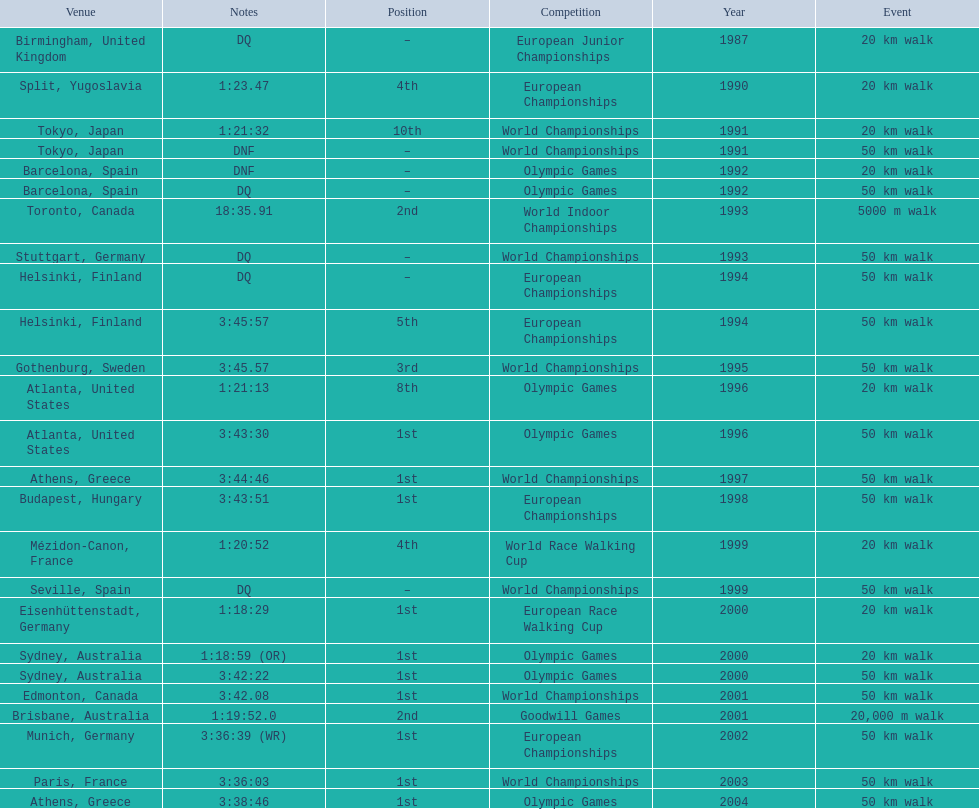In 1990 what position did robert korzeniowski place? 4th. Could you parse the entire table? {'header': ['Venue', 'Notes', 'Position', 'Competition', 'Year', 'Event'], 'rows': [['Birmingham, United Kingdom', 'DQ', '–', 'European Junior Championships', '1987', '20\xa0km walk'], ['Split, Yugoslavia', '1:23.47', '4th', 'European Championships', '1990', '20\xa0km walk'], ['Tokyo, Japan', '1:21:32', '10th', 'World Championships', '1991', '20\xa0km walk'], ['Tokyo, Japan', 'DNF', '–', 'World Championships', '1991', '50\xa0km walk'], ['Barcelona, Spain', 'DNF', '–', 'Olympic Games', '1992', '20\xa0km walk'], ['Barcelona, Spain', 'DQ', '–', 'Olympic Games', '1992', '50\xa0km walk'], ['Toronto, Canada', '18:35.91', '2nd', 'World Indoor Championships', '1993', '5000 m walk'], ['Stuttgart, Germany', 'DQ', '–', 'World Championships', '1993', '50\xa0km walk'], ['Helsinki, Finland', 'DQ', '–', 'European Championships', '1994', '50\xa0km walk'], ['Helsinki, Finland', '3:45:57', '5th', 'European Championships', '1994', '50\xa0km walk'], ['Gothenburg, Sweden', '3:45.57', '3rd', 'World Championships', '1995', '50\xa0km walk'], ['Atlanta, United States', '1:21:13', '8th', 'Olympic Games', '1996', '20\xa0km walk'], ['Atlanta, United States', '3:43:30', '1st', 'Olympic Games', '1996', '50\xa0km walk'], ['Athens, Greece', '3:44:46', '1st', 'World Championships', '1997', '50\xa0km walk'], ['Budapest, Hungary', '3:43:51', '1st', 'European Championships', '1998', '50\xa0km walk'], ['Mézidon-Canon, France', '1:20:52', '4th', 'World Race Walking Cup', '1999', '20\xa0km walk'], ['Seville, Spain', 'DQ', '–', 'World Championships', '1999', '50\xa0km walk'], ['Eisenhüttenstadt, Germany', '1:18:29', '1st', 'European Race Walking Cup', '2000', '20\xa0km walk'], ['Sydney, Australia', '1:18:59 (OR)', '1st', 'Olympic Games', '2000', '20\xa0km walk'], ['Sydney, Australia', '3:42:22', '1st', 'Olympic Games', '2000', '50\xa0km walk'], ['Edmonton, Canada', '3:42.08', '1st', 'World Championships', '2001', '50\xa0km walk'], ['Brisbane, Australia', '1:19:52.0', '2nd', 'Goodwill Games', '2001', '20,000 m walk'], ['Munich, Germany', '3:36:39 (WR)', '1st', 'European Championships', '2002', '50\xa0km walk'], ['Paris, France', '3:36:03', '1st', 'World Championships', '2003', '50\xa0km walk'], ['Athens, Greece', '3:38:46', '1st', 'Olympic Games', '2004', '50\xa0km walk']]} In 1993 what was robert korzeniowski's place in the world indoor championships? 2nd. How long did the 50km walk in 2004 olympic cost? 3:38:46. 